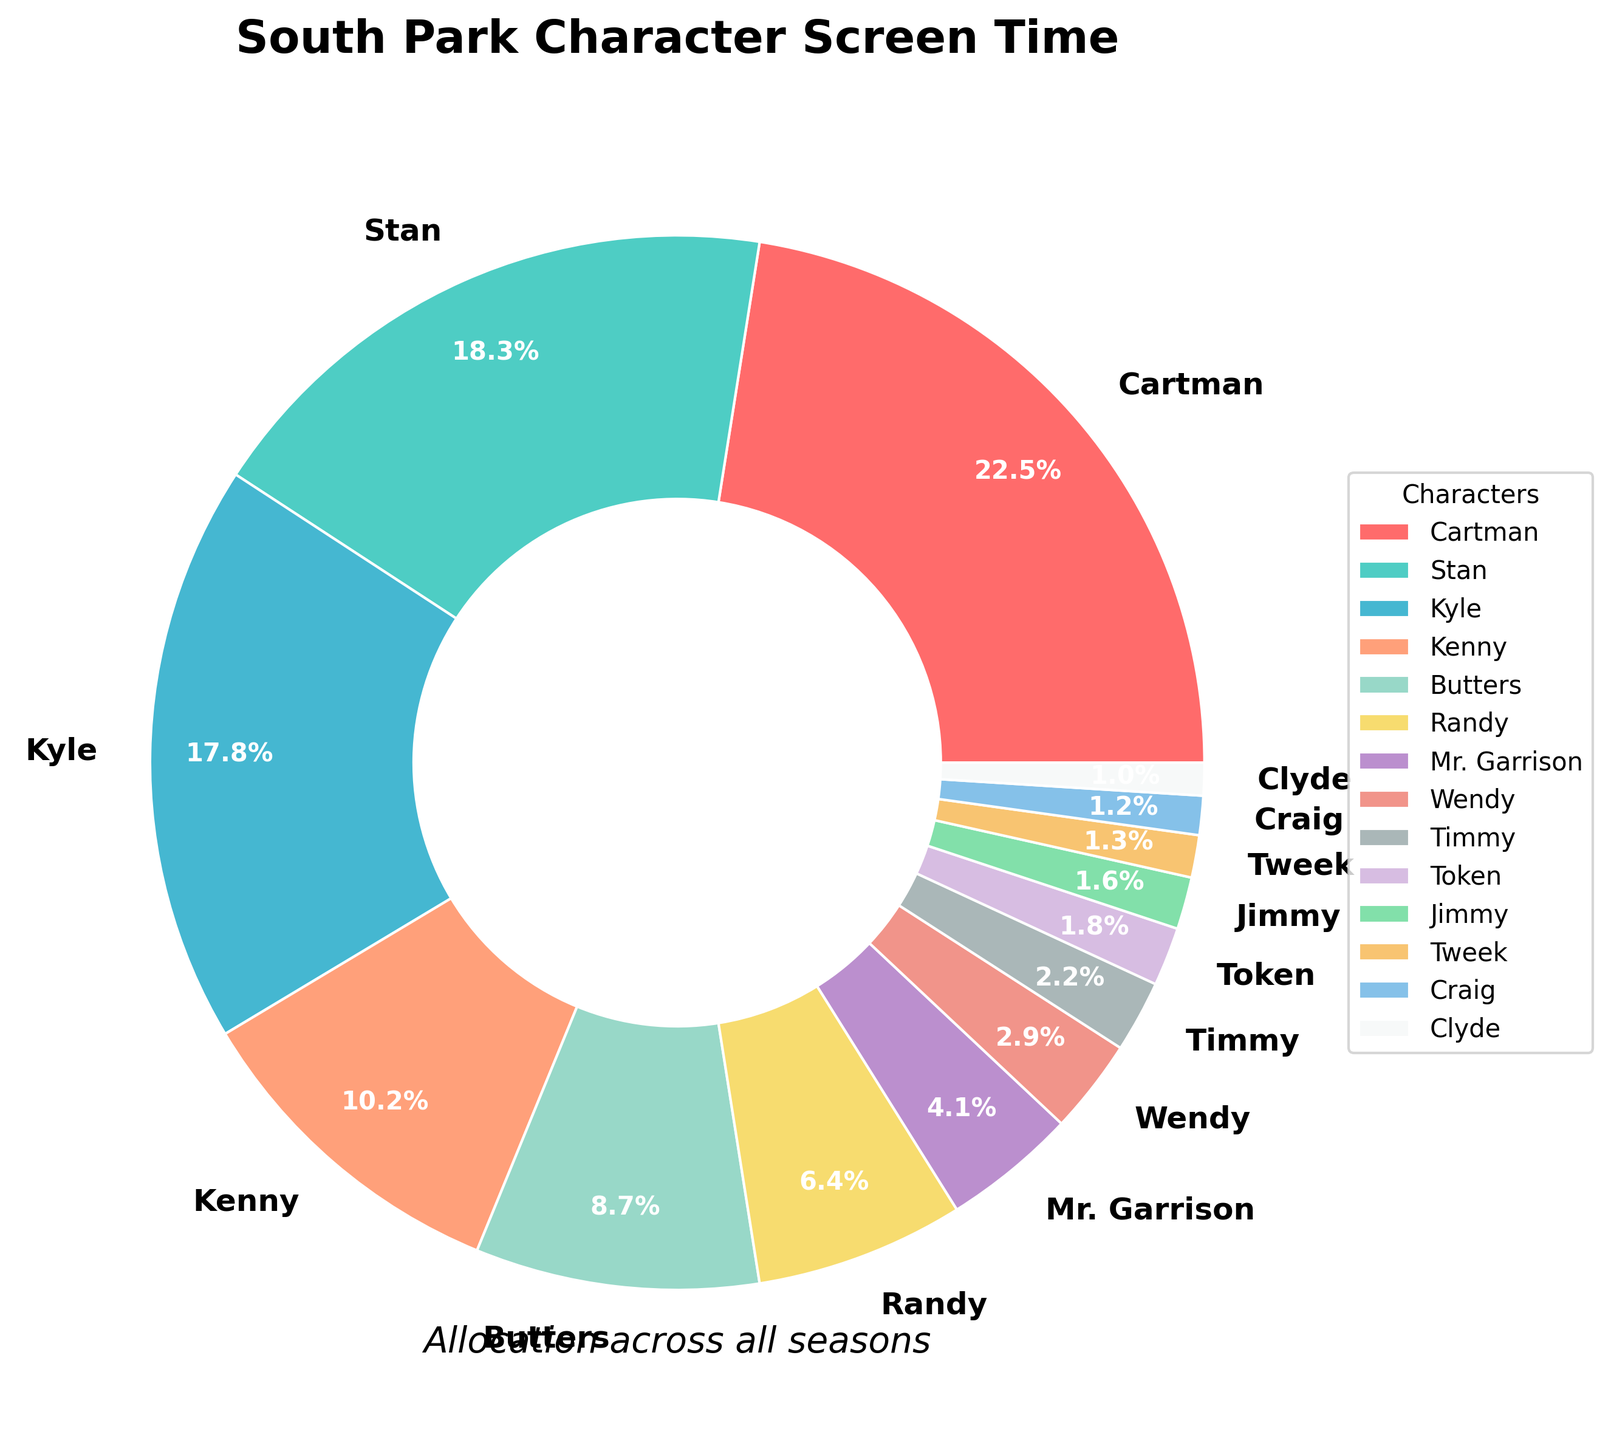Which character has the highest screen time percentage? Cartman has the highest screen time percentage as indicated by the largest slice of the pie chart.
Answer: Cartman What is the combined screen time percentage for Stan and Kyle? The screen time percentage for Stan is 18.3% and for Kyle is 17.8%. Adding these together results in 18.3% + 17.8% = 36.1%.
Answer: 36.1% How much more screen time does Cartman have compared to Kenny? Cartman has a screen time percentage of 22.5% and Kenny has 10.2%. The difference is 22.5% - 10.2% = 12.3%.
Answer: 12.3% Which character has the smallest screen time percentage? Clyde has the smallest screen time percentage, indicated by the smallest slice of the pie chart.
Answer: Clyde What is the average screen time percentage for Butters, Randy, and Mr. Garrison? The screen time percentages are Butters 8.7%, Randy 6.4%, and Mr. Garrison 4.1%. The average is calculated as (8.7% + 6.4% + 4.1%) / 3 = 19.2% / 3 = 6.4%.
Answer: 6.4% Is the screen time percentage of Token higher than that of Jimmy? Token has a screen time percentage of 1.8%, while Jimmy has 1.6%. Thus, Token's screen time percentage is higher.
Answer: Yes What is the total screen time percentage for the four main characters (Stan, Kyle, Cartman, Kenny)? The screen time percentages for the main characters are: Stan 18.3%, Kyle 17.8%, Cartman 22.5%, and Kenny 10.2%. The total is 18.3% + 17.8% + 22.5% + 10.2% = 68.8%.
Answer: 68.8% How does the screen time of Wendy compare to that of Timmy? Wendy has a screen time percentage of 2.9%, while Timmy has 2.2%. Wendy's screen time is higher than Timmy's.
Answer: Wendy has higher screen time Which character appears more frequently, Tweek or Craig? Tweek has a screen time percentage of 1.3%, while Craig has 1.2%. Therefore, Tweek appears more frequently.
Answer: Tweek What is the combined screen time percentage for the characters with less than 5% screen time each? The characters with less than 5% screen time are Randy (6.4% is not < 5%), Mr. Garrison (4.1%), Wendy (2.9%), Timmy (2.2%), Token (1.8%), Jimmy (1.6%), Tweek (1.3%), Craig (1.2%), and Clyde (1.0%). Adding these together results in 4.1% + 2.9% + 2.2% + 1.8% + 1.6% + 1.3% + 1.2% + 1.0% = 16.1%.
Answer: 16.1% 